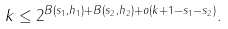<formula> <loc_0><loc_0><loc_500><loc_500>k \leq 2 ^ { B ( s _ { 1 } , h _ { 1 } ) + B ( s _ { 2 } , h _ { 2 } ) + o ( k + 1 - s _ { 1 } - s _ { 2 } ) } .</formula> 